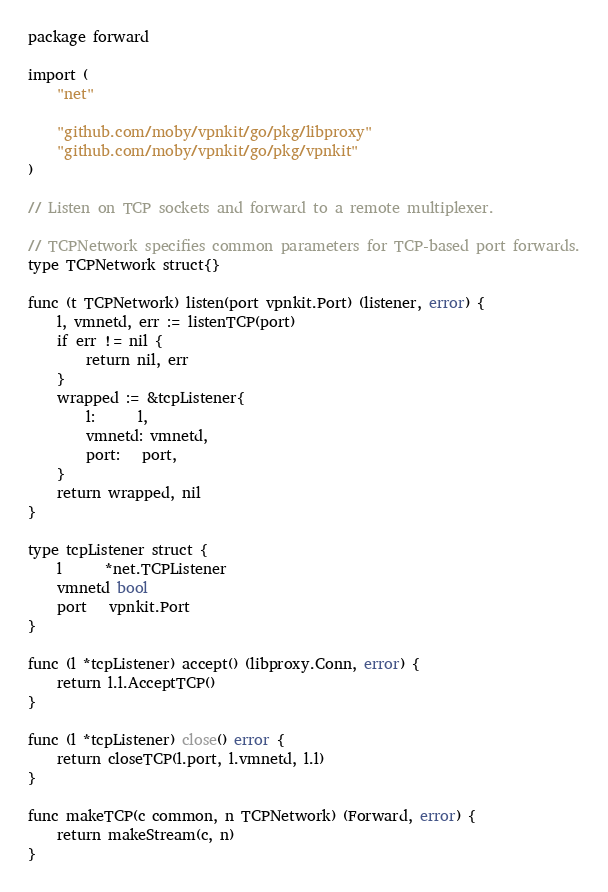<code> <loc_0><loc_0><loc_500><loc_500><_Go_>package forward

import (
	"net"

	"github.com/moby/vpnkit/go/pkg/libproxy"
	"github.com/moby/vpnkit/go/pkg/vpnkit"
)

// Listen on TCP sockets and forward to a remote multiplexer.

// TCPNetwork specifies common parameters for TCP-based port forwards.
type TCPNetwork struct{}

func (t TCPNetwork) listen(port vpnkit.Port) (listener, error) {
	l, vmnetd, err := listenTCP(port)
	if err != nil {
		return nil, err
	}
	wrapped := &tcpListener{
		l:      l,
		vmnetd: vmnetd,
		port:   port,
	}
	return wrapped, nil
}

type tcpListener struct {
	l      *net.TCPListener
	vmnetd bool
	port   vpnkit.Port
}

func (l *tcpListener) accept() (libproxy.Conn, error) {
	return l.l.AcceptTCP()
}

func (l *tcpListener) close() error {
	return closeTCP(l.port, l.vmnetd, l.l)
}

func makeTCP(c common, n TCPNetwork) (Forward, error) {
	return makeStream(c, n)
}
</code> 